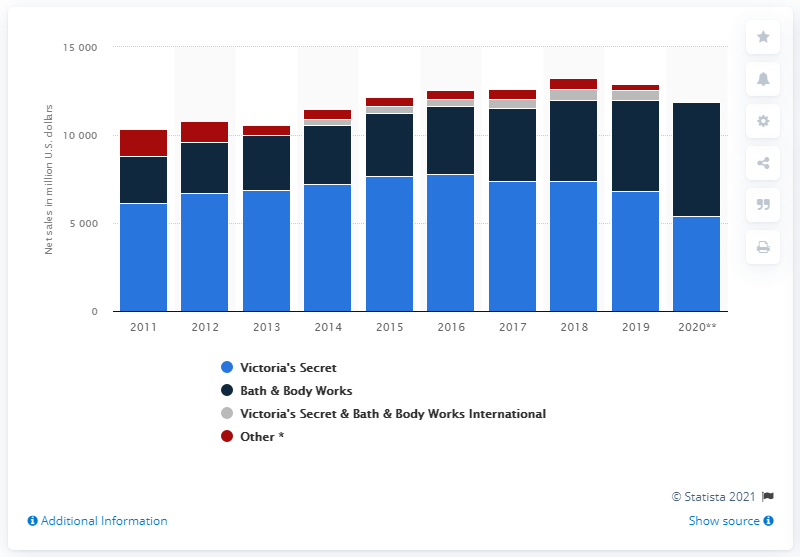Mention a couple of crucial points in this snapshot. In 2020, the global net sales of Bath & Body Works were 6,434. 